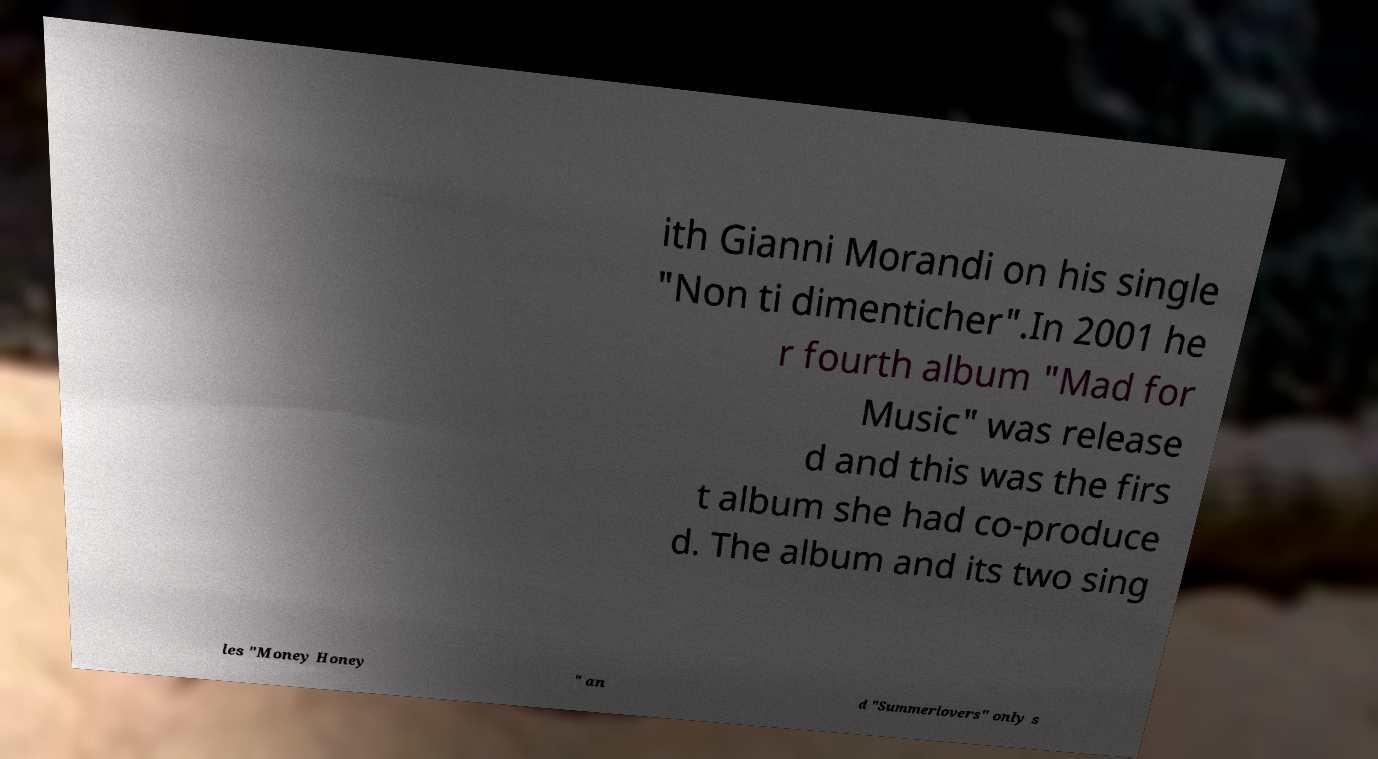Can you read and provide the text displayed in the image?This photo seems to have some interesting text. Can you extract and type it out for me? ith Gianni Morandi on his single "Non ti dimenticher".In 2001 he r fourth album "Mad for Music" was release d and this was the firs t album she had co-produce d. The album and its two sing les "Money Honey " an d "Summerlovers" only s 